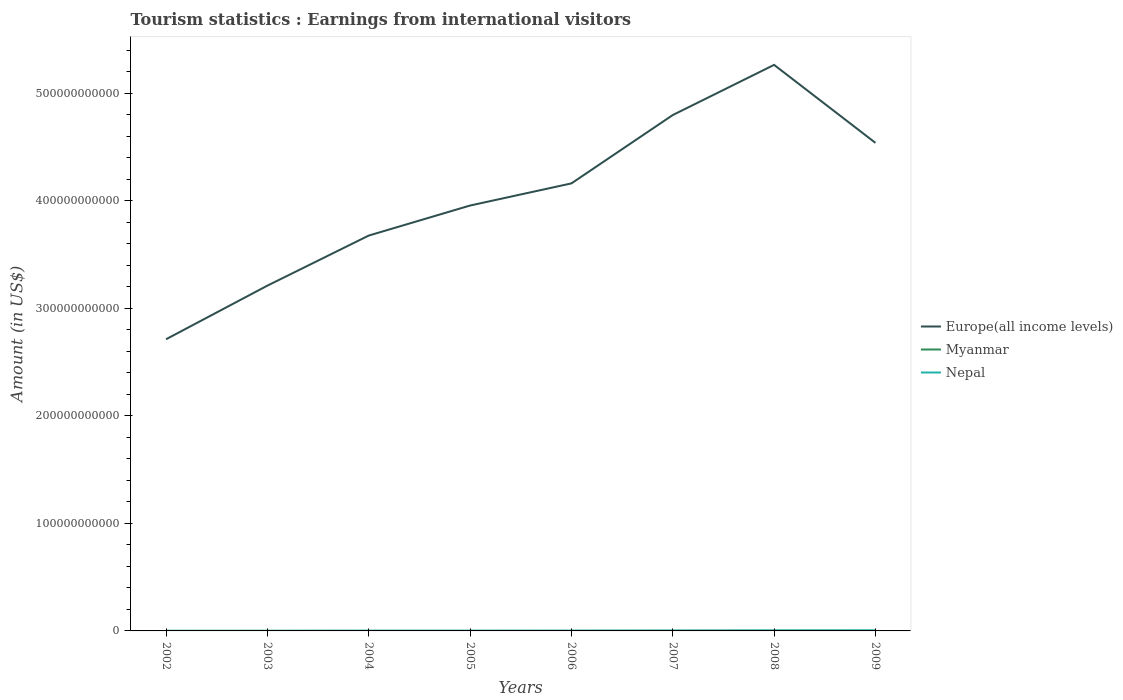How many different coloured lines are there?
Provide a succinct answer. 3. Is the number of lines equal to the number of legend labels?
Keep it short and to the point. Yes. Across all years, what is the maximum earnings from international visitors in Europe(all income levels)?
Offer a very short reply. 2.71e+11. What is the total earnings from international visitors in Europe(all income levels) in the graph?
Offer a terse response. -9.51e+1. What is the difference between the highest and the second highest earnings from international visitors in Europe(all income levels)?
Keep it short and to the point. 2.55e+11. What is the difference between two consecutive major ticks on the Y-axis?
Provide a succinct answer. 1.00e+11. Does the graph contain grids?
Offer a terse response. No. What is the title of the graph?
Provide a short and direct response. Tourism statistics : Earnings from international visitors. Does "Djibouti" appear as one of the legend labels in the graph?
Your response must be concise. No. What is the label or title of the Y-axis?
Give a very brief answer. Amount (in US$). What is the Amount (in US$) of Europe(all income levels) in 2002?
Offer a very short reply. 2.71e+11. What is the Amount (in US$) of Myanmar in 2002?
Your answer should be compact. 3.40e+07. What is the Amount (in US$) of Nepal in 2002?
Your answer should be compact. 1.08e+08. What is the Amount (in US$) of Europe(all income levels) in 2003?
Give a very brief answer. 3.21e+11. What is the Amount (in US$) in Myanmar in 2003?
Provide a short and direct response. 3.60e+07. What is the Amount (in US$) in Nepal in 2003?
Offer a terse response. 1.19e+08. What is the Amount (in US$) of Europe(all income levels) in 2004?
Your answer should be compact. 3.68e+11. What is the Amount (in US$) of Myanmar in 2004?
Your answer should be very brief. 3.20e+07. What is the Amount (in US$) in Nepal in 2004?
Offer a terse response. 2.05e+08. What is the Amount (in US$) of Europe(all income levels) in 2005?
Give a very brief answer. 3.96e+11. What is the Amount (in US$) in Myanmar in 2005?
Provide a short and direct response. 3.40e+07. What is the Amount (in US$) in Nepal in 2005?
Offer a very short reply. 2.21e+08. What is the Amount (in US$) in Europe(all income levels) in 2006?
Your answer should be compact. 4.16e+11. What is the Amount (in US$) of Myanmar in 2006?
Give a very brief answer. 4.00e+07. What is the Amount (in US$) in Nepal in 2006?
Ensure brevity in your answer.  2.61e+08. What is the Amount (in US$) of Europe(all income levels) in 2007?
Make the answer very short. 4.80e+11. What is the Amount (in US$) of Myanmar in 2007?
Provide a succinct answer. 3.90e+07. What is the Amount (in US$) of Nepal in 2007?
Give a very brief answer. 4.02e+08. What is the Amount (in US$) of Europe(all income levels) in 2008?
Provide a succinct answer. 5.26e+11. What is the Amount (in US$) in Myanmar in 2008?
Ensure brevity in your answer.  4.97e+07. What is the Amount (in US$) of Nepal in 2008?
Your answer should be very brief. 5.45e+08. What is the Amount (in US$) of Europe(all income levels) in 2009?
Give a very brief answer. 4.54e+11. What is the Amount (in US$) of Myanmar in 2009?
Keep it short and to the point. 5.20e+07. What is the Amount (in US$) in Nepal in 2009?
Give a very brief answer. 5.72e+08. Across all years, what is the maximum Amount (in US$) of Europe(all income levels)?
Give a very brief answer. 5.26e+11. Across all years, what is the maximum Amount (in US$) of Myanmar?
Your answer should be very brief. 5.20e+07. Across all years, what is the maximum Amount (in US$) in Nepal?
Provide a short and direct response. 5.72e+08. Across all years, what is the minimum Amount (in US$) of Europe(all income levels)?
Your response must be concise. 2.71e+11. Across all years, what is the minimum Amount (in US$) in Myanmar?
Offer a very short reply. 3.20e+07. Across all years, what is the minimum Amount (in US$) of Nepal?
Offer a very short reply. 1.08e+08. What is the total Amount (in US$) in Europe(all income levels) in the graph?
Your response must be concise. 3.23e+12. What is the total Amount (in US$) of Myanmar in the graph?
Your answer should be very brief. 3.17e+08. What is the total Amount (in US$) in Nepal in the graph?
Keep it short and to the point. 2.43e+09. What is the difference between the Amount (in US$) of Europe(all income levels) in 2002 and that in 2003?
Your answer should be compact. -4.99e+1. What is the difference between the Amount (in US$) in Myanmar in 2002 and that in 2003?
Keep it short and to the point. -2.00e+06. What is the difference between the Amount (in US$) of Nepal in 2002 and that in 2003?
Make the answer very short. -1.10e+07. What is the difference between the Amount (in US$) of Europe(all income levels) in 2002 and that in 2004?
Your response must be concise. -9.64e+1. What is the difference between the Amount (in US$) of Myanmar in 2002 and that in 2004?
Keep it short and to the point. 2.00e+06. What is the difference between the Amount (in US$) in Nepal in 2002 and that in 2004?
Your answer should be compact. -9.70e+07. What is the difference between the Amount (in US$) of Europe(all income levels) in 2002 and that in 2005?
Your response must be concise. -1.24e+11. What is the difference between the Amount (in US$) in Myanmar in 2002 and that in 2005?
Offer a terse response. 0. What is the difference between the Amount (in US$) of Nepal in 2002 and that in 2005?
Ensure brevity in your answer.  -1.13e+08. What is the difference between the Amount (in US$) of Europe(all income levels) in 2002 and that in 2006?
Provide a short and direct response. -1.45e+11. What is the difference between the Amount (in US$) of Myanmar in 2002 and that in 2006?
Your answer should be compact. -6.00e+06. What is the difference between the Amount (in US$) of Nepal in 2002 and that in 2006?
Your answer should be very brief. -1.53e+08. What is the difference between the Amount (in US$) in Europe(all income levels) in 2002 and that in 2007?
Ensure brevity in your answer.  -2.09e+11. What is the difference between the Amount (in US$) in Myanmar in 2002 and that in 2007?
Offer a terse response. -5.00e+06. What is the difference between the Amount (in US$) in Nepal in 2002 and that in 2007?
Give a very brief answer. -2.94e+08. What is the difference between the Amount (in US$) in Europe(all income levels) in 2002 and that in 2008?
Keep it short and to the point. -2.55e+11. What is the difference between the Amount (in US$) of Myanmar in 2002 and that in 2008?
Your response must be concise. -1.57e+07. What is the difference between the Amount (in US$) in Nepal in 2002 and that in 2008?
Keep it short and to the point. -4.37e+08. What is the difference between the Amount (in US$) of Europe(all income levels) in 2002 and that in 2009?
Your response must be concise. -1.83e+11. What is the difference between the Amount (in US$) of Myanmar in 2002 and that in 2009?
Offer a very short reply. -1.80e+07. What is the difference between the Amount (in US$) of Nepal in 2002 and that in 2009?
Offer a very short reply. -4.64e+08. What is the difference between the Amount (in US$) in Europe(all income levels) in 2003 and that in 2004?
Offer a very short reply. -4.66e+1. What is the difference between the Amount (in US$) of Myanmar in 2003 and that in 2004?
Ensure brevity in your answer.  4.00e+06. What is the difference between the Amount (in US$) in Nepal in 2003 and that in 2004?
Give a very brief answer. -8.60e+07. What is the difference between the Amount (in US$) in Europe(all income levels) in 2003 and that in 2005?
Ensure brevity in your answer.  -7.45e+1. What is the difference between the Amount (in US$) of Myanmar in 2003 and that in 2005?
Make the answer very short. 2.00e+06. What is the difference between the Amount (in US$) in Nepal in 2003 and that in 2005?
Offer a terse response. -1.02e+08. What is the difference between the Amount (in US$) of Europe(all income levels) in 2003 and that in 2006?
Your response must be concise. -9.51e+1. What is the difference between the Amount (in US$) in Nepal in 2003 and that in 2006?
Your answer should be very brief. -1.42e+08. What is the difference between the Amount (in US$) of Europe(all income levels) in 2003 and that in 2007?
Your response must be concise. -1.59e+11. What is the difference between the Amount (in US$) in Myanmar in 2003 and that in 2007?
Provide a short and direct response. -3.00e+06. What is the difference between the Amount (in US$) of Nepal in 2003 and that in 2007?
Your answer should be very brief. -2.83e+08. What is the difference between the Amount (in US$) in Europe(all income levels) in 2003 and that in 2008?
Give a very brief answer. -2.05e+11. What is the difference between the Amount (in US$) in Myanmar in 2003 and that in 2008?
Offer a very short reply. -1.37e+07. What is the difference between the Amount (in US$) in Nepal in 2003 and that in 2008?
Give a very brief answer. -4.26e+08. What is the difference between the Amount (in US$) of Europe(all income levels) in 2003 and that in 2009?
Your answer should be compact. -1.33e+11. What is the difference between the Amount (in US$) in Myanmar in 2003 and that in 2009?
Offer a very short reply. -1.60e+07. What is the difference between the Amount (in US$) in Nepal in 2003 and that in 2009?
Offer a very short reply. -4.53e+08. What is the difference between the Amount (in US$) in Europe(all income levels) in 2004 and that in 2005?
Keep it short and to the point. -2.79e+1. What is the difference between the Amount (in US$) in Myanmar in 2004 and that in 2005?
Make the answer very short. -2.00e+06. What is the difference between the Amount (in US$) in Nepal in 2004 and that in 2005?
Keep it short and to the point. -1.60e+07. What is the difference between the Amount (in US$) of Europe(all income levels) in 2004 and that in 2006?
Ensure brevity in your answer.  -4.85e+1. What is the difference between the Amount (in US$) in Myanmar in 2004 and that in 2006?
Your answer should be compact. -8.00e+06. What is the difference between the Amount (in US$) in Nepal in 2004 and that in 2006?
Your answer should be compact. -5.60e+07. What is the difference between the Amount (in US$) in Europe(all income levels) in 2004 and that in 2007?
Your answer should be very brief. -1.12e+11. What is the difference between the Amount (in US$) of Myanmar in 2004 and that in 2007?
Your response must be concise. -7.00e+06. What is the difference between the Amount (in US$) in Nepal in 2004 and that in 2007?
Offer a terse response. -1.97e+08. What is the difference between the Amount (in US$) of Europe(all income levels) in 2004 and that in 2008?
Give a very brief answer. -1.59e+11. What is the difference between the Amount (in US$) of Myanmar in 2004 and that in 2008?
Offer a very short reply. -1.77e+07. What is the difference between the Amount (in US$) of Nepal in 2004 and that in 2008?
Make the answer very short. -3.40e+08. What is the difference between the Amount (in US$) of Europe(all income levels) in 2004 and that in 2009?
Keep it short and to the point. -8.62e+1. What is the difference between the Amount (in US$) of Myanmar in 2004 and that in 2009?
Your answer should be compact. -2.00e+07. What is the difference between the Amount (in US$) in Nepal in 2004 and that in 2009?
Your answer should be very brief. -3.67e+08. What is the difference between the Amount (in US$) of Europe(all income levels) in 2005 and that in 2006?
Give a very brief answer. -2.06e+1. What is the difference between the Amount (in US$) in Myanmar in 2005 and that in 2006?
Make the answer very short. -6.00e+06. What is the difference between the Amount (in US$) in Nepal in 2005 and that in 2006?
Make the answer very short. -4.00e+07. What is the difference between the Amount (in US$) of Europe(all income levels) in 2005 and that in 2007?
Your answer should be very brief. -8.42e+1. What is the difference between the Amount (in US$) of Myanmar in 2005 and that in 2007?
Provide a succinct answer. -5.00e+06. What is the difference between the Amount (in US$) of Nepal in 2005 and that in 2007?
Your response must be concise. -1.81e+08. What is the difference between the Amount (in US$) in Europe(all income levels) in 2005 and that in 2008?
Keep it short and to the point. -1.31e+11. What is the difference between the Amount (in US$) in Myanmar in 2005 and that in 2008?
Provide a short and direct response. -1.57e+07. What is the difference between the Amount (in US$) of Nepal in 2005 and that in 2008?
Offer a very short reply. -3.24e+08. What is the difference between the Amount (in US$) in Europe(all income levels) in 2005 and that in 2009?
Provide a short and direct response. -5.83e+1. What is the difference between the Amount (in US$) of Myanmar in 2005 and that in 2009?
Provide a succinct answer. -1.80e+07. What is the difference between the Amount (in US$) in Nepal in 2005 and that in 2009?
Your answer should be compact. -3.51e+08. What is the difference between the Amount (in US$) of Europe(all income levels) in 2006 and that in 2007?
Provide a succinct answer. -6.36e+1. What is the difference between the Amount (in US$) of Myanmar in 2006 and that in 2007?
Your answer should be compact. 1.00e+06. What is the difference between the Amount (in US$) in Nepal in 2006 and that in 2007?
Give a very brief answer. -1.41e+08. What is the difference between the Amount (in US$) of Europe(all income levels) in 2006 and that in 2008?
Give a very brief answer. -1.10e+11. What is the difference between the Amount (in US$) of Myanmar in 2006 and that in 2008?
Your answer should be very brief. -9.70e+06. What is the difference between the Amount (in US$) of Nepal in 2006 and that in 2008?
Offer a terse response. -2.84e+08. What is the difference between the Amount (in US$) of Europe(all income levels) in 2006 and that in 2009?
Your answer should be compact. -3.77e+1. What is the difference between the Amount (in US$) in Myanmar in 2006 and that in 2009?
Provide a succinct answer. -1.20e+07. What is the difference between the Amount (in US$) in Nepal in 2006 and that in 2009?
Your response must be concise. -3.11e+08. What is the difference between the Amount (in US$) of Europe(all income levels) in 2007 and that in 2008?
Offer a very short reply. -4.67e+1. What is the difference between the Amount (in US$) in Myanmar in 2007 and that in 2008?
Offer a very short reply. -1.07e+07. What is the difference between the Amount (in US$) in Nepal in 2007 and that in 2008?
Give a very brief answer. -1.43e+08. What is the difference between the Amount (in US$) of Europe(all income levels) in 2007 and that in 2009?
Keep it short and to the point. 2.59e+1. What is the difference between the Amount (in US$) of Myanmar in 2007 and that in 2009?
Your answer should be compact. -1.30e+07. What is the difference between the Amount (in US$) in Nepal in 2007 and that in 2009?
Your response must be concise. -1.70e+08. What is the difference between the Amount (in US$) of Europe(all income levels) in 2008 and that in 2009?
Your answer should be very brief. 7.25e+1. What is the difference between the Amount (in US$) in Myanmar in 2008 and that in 2009?
Give a very brief answer. -2.30e+06. What is the difference between the Amount (in US$) of Nepal in 2008 and that in 2009?
Your answer should be compact. -2.70e+07. What is the difference between the Amount (in US$) in Europe(all income levels) in 2002 and the Amount (in US$) in Myanmar in 2003?
Your answer should be compact. 2.71e+11. What is the difference between the Amount (in US$) in Europe(all income levels) in 2002 and the Amount (in US$) in Nepal in 2003?
Make the answer very short. 2.71e+11. What is the difference between the Amount (in US$) in Myanmar in 2002 and the Amount (in US$) in Nepal in 2003?
Your answer should be very brief. -8.50e+07. What is the difference between the Amount (in US$) of Europe(all income levels) in 2002 and the Amount (in US$) of Myanmar in 2004?
Make the answer very short. 2.71e+11. What is the difference between the Amount (in US$) of Europe(all income levels) in 2002 and the Amount (in US$) of Nepal in 2004?
Your answer should be very brief. 2.71e+11. What is the difference between the Amount (in US$) of Myanmar in 2002 and the Amount (in US$) of Nepal in 2004?
Your answer should be very brief. -1.71e+08. What is the difference between the Amount (in US$) in Europe(all income levels) in 2002 and the Amount (in US$) in Myanmar in 2005?
Your response must be concise. 2.71e+11. What is the difference between the Amount (in US$) of Europe(all income levels) in 2002 and the Amount (in US$) of Nepal in 2005?
Keep it short and to the point. 2.71e+11. What is the difference between the Amount (in US$) in Myanmar in 2002 and the Amount (in US$) in Nepal in 2005?
Provide a short and direct response. -1.87e+08. What is the difference between the Amount (in US$) of Europe(all income levels) in 2002 and the Amount (in US$) of Myanmar in 2006?
Give a very brief answer. 2.71e+11. What is the difference between the Amount (in US$) of Europe(all income levels) in 2002 and the Amount (in US$) of Nepal in 2006?
Make the answer very short. 2.71e+11. What is the difference between the Amount (in US$) of Myanmar in 2002 and the Amount (in US$) of Nepal in 2006?
Provide a succinct answer. -2.27e+08. What is the difference between the Amount (in US$) in Europe(all income levels) in 2002 and the Amount (in US$) in Myanmar in 2007?
Offer a terse response. 2.71e+11. What is the difference between the Amount (in US$) of Europe(all income levels) in 2002 and the Amount (in US$) of Nepal in 2007?
Keep it short and to the point. 2.71e+11. What is the difference between the Amount (in US$) of Myanmar in 2002 and the Amount (in US$) of Nepal in 2007?
Offer a terse response. -3.68e+08. What is the difference between the Amount (in US$) in Europe(all income levels) in 2002 and the Amount (in US$) in Myanmar in 2008?
Your answer should be compact. 2.71e+11. What is the difference between the Amount (in US$) of Europe(all income levels) in 2002 and the Amount (in US$) of Nepal in 2008?
Offer a very short reply. 2.71e+11. What is the difference between the Amount (in US$) of Myanmar in 2002 and the Amount (in US$) of Nepal in 2008?
Your answer should be compact. -5.11e+08. What is the difference between the Amount (in US$) of Europe(all income levels) in 2002 and the Amount (in US$) of Myanmar in 2009?
Offer a terse response. 2.71e+11. What is the difference between the Amount (in US$) in Europe(all income levels) in 2002 and the Amount (in US$) in Nepal in 2009?
Keep it short and to the point. 2.71e+11. What is the difference between the Amount (in US$) of Myanmar in 2002 and the Amount (in US$) of Nepal in 2009?
Your response must be concise. -5.38e+08. What is the difference between the Amount (in US$) of Europe(all income levels) in 2003 and the Amount (in US$) of Myanmar in 2004?
Give a very brief answer. 3.21e+11. What is the difference between the Amount (in US$) in Europe(all income levels) in 2003 and the Amount (in US$) in Nepal in 2004?
Ensure brevity in your answer.  3.21e+11. What is the difference between the Amount (in US$) in Myanmar in 2003 and the Amount (in US$) in Nepal in 2004?
Make the answer very short. -1.69e+08. What is the difference between the Amount (in US$) in Europe(all income levels) in 2003 and the Amount (in US$) in Myanmar in 2005?
Give a very brief answer. 3.21e+11. What is the difference between the Amount (in US$) in Europe(all income levels) in 2003 and the Amount (in US$) in Nepal in 2005?
Offer a terse response. 3.21e+11. What is the difference between the Amount (in US$) of Myanmar in 2003 and the Amount (in US$) of Nepal in 2005?
Give a very brief answer. -1.85e+08. What is the difference between the Amount (in US$) in Europe(all income levels) in 2003 and the Amount (in US$) in Myanmar in 2006?
Offer a very short reply. 3.21e+11. What is the difference between the Amount (in US$) in Europe(all income levels) in 2003 and the Amount (in US$) in Nepal in 2006?
Offer a very short reply. 3.21e+11. What is the difference between the Amount (in US$) of Myanmar in 2003 and the Amount (in US$) of Nepal in 2006?
Give a very brief answer. -2.25e+08. What is the difference between the Amount (in US$) of Europe(all income levels) in 2003 and the Amount (in US$) of Myanmar in 2007?
Provide a short and direct response. 3.21e+11. What is the difference between the Amount (in US$) of Europe(all income levels) in 2003 and the Amount (in US$) of Nepal in 2007?
Offer a terse response. 3.21e+11. What is the difference between the Amount (in US$) of Myanmar in 2003 and the Amount (in US$) of Nepal in 2007?
Your response must be concise. -3.66e+08. What is the difference between the Amount (in US$) of Europe(all income levels) in 2003 and the Amount (in US$) of Myanmar in 2008?
Offer a very short reply. 3.21e+11. What is the difference between the Amount (in US$) of Europe(all income levels) in 2003 and the Amount (in US$) of Nepal in 2008?
Keep it short and to the point. 3.21e+11. What is the difference between the Amount (in US$) of Myanmar in 2003 and the Amount (in US$) of Nepal in 2008?
Keep it short and to the point. -5.09e+08. What is the difference between the Amount (in US$) in Europe(all income levels) in 2003 and the Amount (in US$) in Myanmar in 2009?
Offer a terse response. 3.21e+11. What is the difference between the Amount (in US$) in Europe(all income levels) in 2003 and the Amount (in US$) in Nepal in 2009?
Ensure brevity in your answer.  3.21e+11. What is the difference between the Amount (in US$) of Myanmar in 2003 and the Amount (in US$) of Nepal in 2009?
Offer a terse response. -5.36e+08. What is the difference between the Amount (in US$) of Europe(all income levels) in 2004 and the Amount (in US$) of Myanmar in 2005?
Your answer should be compact. 3.68e+11. What is the difference between the Amount (in US$) in Europe(all income levels) in 2004 and the Amount (in US$) in Nepal in 2005?
Your answer should be compact. 3.67e+11. What is the difference between the Amount (in US$) of Myanmar in 2004 and the Amount (in US$) of Nepal in 2005?
Ensure brevity in your answer.  -1.89e+08. What is the difference between the Amount (in US$) in Europe(all income levels) in 2004 and the Amount (in US$) in Myanmar in 2006?
Offer a very short reply. 3.68e+11. What is the difference between the Amount (in US$) in Europe(all income levels) in 2004 and the Amount (in US$) in Nepal in 2006?
Offer a terse response. 3.67e+11. What is the difference between the Amount (in US$) of Myanmar in 2004 and the Amount (in US$) of Nepal in 2006?
Give a very brief answer. -2.29e+08. What is the difference between the Amount (in US$) of Europe(all income levels) in 2004 and the Amount (in US$) of Myanmar in 2007?
Offer a very short reply. 3.68e+11. What is the difference between the Amount (in US$) of Europe(all income levels) in 2004 and the Amount (in US$) of Nepal in 2007?
Offer a very short reply. 3.67e+11. What is the difference between the Amount (in US$) of Myanmar in 2004 and the Amount (in US$) of Nepal in 2007?
Ensure brevity in your answer.  -3.70e+08. What is the difference between the Amount (in US$) in Europe(all income levels) in 2004 and the Amount (in US$) in Myanmar in 2008?
Your response must be concise. 3.68e+11. What is the difference between the Amount (in US$) of Europe(all income levels) in 2004 and the Amount (in US$) of Nepal in 2008?
Your answer should be very brief. 3.67e+11. What is the difference between the Amount (in US$) of Myanmar in 2004 and the Amount (in US$) of Nepal in 2008?
Provide a short and direct response. -5.13e+08. What is the difference between the Amount (in US$) in Europe(all income levels) in 2004 and the Amount (in US$) in Myanmar in 2009?
Ensure brevity in your answer.  3.68e+11. What is the difference between the Amount (in US$) in Europe(all income levels) in 2004 and the Amount (in US$) in Nepal in 2009?
Ensure brevity in your answer.  3.67e+11. What is the difference between the Amount (in US$) of Myanmar in 2004 and the Amount (in US$) of Nepal in 2009?
Give a very brief answer. -5.40e+08. What is the difference between the Amount (in US$) in Europe(all income levels) in 2005 and the Amount (in US$) in Myanmar in 2006?
Make the answer very short. 3.96e+11. What is the difference between the Amount (in US$) of Europe(all income levels) in 2005 and the Amount (in US$) of Nepal in 2006?
Make the answer very short. 3.95e+11. What is the difference between the Amount (in US$) of Myanmar in 2005 and the Amount (in US$) of Nepal in 2006?
Offer a very short reply. -2.27e+08. What is the difference between the Amount (in US$) in Europe(all income levels) in 2005 and the Amount (in US$) in Myanmar in 2007?
Your answer should be very brief. 3.96e+11. What is the difference between the Amount (in US$) of Europe(all income levels) in 2005 and the Amount (in US$) of Nepal in 2007?
Keep it short and to the point. 3.95e+11. What is the difference between the Amount (in US$) of Myanmar in 2005 and the Amount (in US$) of Nepal in 2007?
Provide a succinct answer. -3.68e+08. What is the difference between the Amount (in US$) of Europe(all income levels) in 2005 and the Amount (in US$) of Myanmar in 2008?
Provide a short and direct response. 3.96e+11. What is the difference between the Amount (in US$) of Europe(all income levels) in 2005 and the Amount (in US$) of Nepal in 2008?
Provide a succinct answer. 3.95e+11. What is the difference between the Amount (in US$) in Myanmar in 2005 and the Amount (in US$) in Nepal in 2008?
Give a very brief answer. -5.11e+08. What is the difference between the Amount (in US$) in Europe(all income levels) in 2005 and the Amount (in US$) in Myanmar in 2009?
Provide a succinct answer. 3.96e+11. What is the difference between the Amount (in US$) of Europe(all income levels) in 2005 and the Amount (in US$) of Nepal in 2009?
Offer a terse response. 3.95e+11. What is the difference between the Amount (in US$) in Myanmar in 2005 and the Amount (in US$) in Nepal in 2009?
Your response must be concise. -5.38e+08. What is the difference between the Amount (in US$) in Europe(all income levels) in 2006 and the Amount (in US$) in Myanmar in 2007?
Provide a short and direct response. 4.16e+11. What is the difference between the Amount (in US$) in Europe(all income levels) in 2006 and the Amount (in US$) in Nepal in 2007?
Your answer should be compact. 4.16e+11. What is the difference between the Amount (in US$) of Myanmar in 2006 and the Amount (in US$) of Nepal in 2007?
Offer a terse response. -3.62e+08. What is the difference between the Amount (in US$) of Europe(all income levels) in 2006 and the Amount (in US$) of Myanmar in 2008?
Provide a short and direct response. 4.16e+11. What is the difference between the Amount (in US$) of Europe(all income levels) in 2006 and the Amount (in US$) of Nepal in 2008?
Your response must be concise. 4.16e+11. What is the difference between the Amount (in US$) of Myanmar in 2006 and the Amount (in US$) of Nepal in 2008?
Your answer should be compact. -5.05e+08. What is the difference between the Amount (in US$) in Europe(all income levels) in 2006 and the Amount (in US$) in Myanmar in 2009?
Offer a very short reply. 4.16e+11. What is the difference between the Amount (in US$) of Europe(all income levels) in 2006 and the Amount (in US$) of Nepal in 2009?
Provide a succinct answer. 4.16e+11. What is the difference between the Amount (in US$) of Myanmar in 2006 and the Amount (in US$) of Nepal in 2009?
Offer a very short reply. -5.32e+08. What is the difference between the Amount (in US$) of Europe(all income levels) in 2007 and the Amount (in US$) of Myanmar in 2008?
Provide a short and direct response. 4.80e+11. What is the difference between the Amount (in US$) in Europe(all income levels) in 2007 and the Amount (in US$) in Nepal in 2008?
Provide a succinct answer. 4.79e+11. What is the difference between the Amount (in US$) in Myanmar in 2007 and the Amount (in US$) in Nepal in 2008?
Your response must be concise. -5.06e+08. What is the difference between the Amount (in US$) of Europe(all income levels) in 2007 and the Amount (in US$) of Myanmar in 2009?
Make the answer very short. 4.80e+11. What is the difference between the Amount (in US$) in Europe(all income levels) in 2007 and the Amount (in US$) in Nepal in 2009?
Provide a short and direct response. 4.79e+11. What is the difference between the Amount (in US$) of Myanmar in 2007 and the Amount (in US$) of Nepal in 2009?
Give a very brief answer. -5.33e+08. What is the difference between the Amount (in US$) of Europe(all income levels) in 2008 and the Amount (in US$) of Myanmar in 2009?
Give a very brief answer. 5.26e+11. What is the difference between the Amount (in US$) of Europe(all income levels) in 2008 and the Amount (in US$) of Nepal in 2009?
Your answer should be very brief. 5.26e+11. What is the difference between the Amount (in US$) in Myanmar in 2008 and the Amount (in US$) in Nepal in 2009?
Your response must be concise. -5.22e+08. What is the average Amount (in US$) in Europe(all income levels) per year?
Give a very brief answer. 4.04e+11. What is the average Amount (in US$) of Myanmar per year?
Offer a very short reply. 3.96e+07. What is the average Amount (in US$) in Nepal per year?
Give a very brief answer. 3.04e+08. In the year 2002, what is the difference between the Amount (in US$) of Europe(all income levels) and Amount (in US$) of Myanmar?
Offer a very short reply. 2.71e+11. In the year 2002, what is the difference between the Amount (in US$) of Europe(all income levels) and Amount (in US$) of Nepal?
Keep it short and to the point. 2.71e+11. In the year 2002, what is the difference between the Amount (in US$) of Myanmar and Amount (in US$) of Nepal?
Offer a terse response. -7.40e+07. In the year 2003, what is the difference between the Amount (in US$) of Europe(all income levels) and Amount (in US$) of Myanmar?
Give a very brief answer. 3.21e+11. In the year 2003, what is the difference between the Amount (in US$) of Europe(all income levels) and Amount (in US$) of Nepal?
Offer a terse response. 3.21e+11. In the year 2003, what is the difference between the Amount (in US$) in Myanmar and Amount (in US$) in Nepal?
Your answer should be very brief. -8.30e+07. In the year 2004, what is the difference between the Amount (in US$) in Europe(all income levels) and Amount (in US$) in Myanmar?
Your answer should be very brief. 3.68e+11. In the year 2004, what is the difference between the Amount (in US$) of Europe(all income levels) and Amount (in US$) of Nepal?
Ensure brevity in your answer.  3.67e+11. In the year 2004, what is the difference between the Amount (in US$) of Myanmar and Amount (in US$) of Nepal?
Your response must be concise. -1.73e+08. In the year 2005, what is the difference between the Amount (in US$) of Europe(all income levels) and Amount (in US$) of Myanmar?
Your response must be concise. 3.96e+11. In the year 2005, what is the difference between the Amount (in US$) in Europe(all income levels) and Amount (in US$) in Nepal?
Offer a very short reply. 3.95e+11. In the year 2005, what is the difference between the Amount (in US$) in Myanmar and Amount (in US$) in Nepal?
Ensure brevity in your answer.  -1.87e+08. In the year 2006, what is the difference between the Amount (in US$) of Europe(all income levels) and Amount (in US$) of Myanmar?
Your answer should be compact. 4.16e+11. In the year 2006, what is the difference between the Amount (in US$) in Europe(all income levels) and Amount (in US$) in Nepal?
Offer a very short reply. 4.16e+11. In the year 2006, what is the difference between the Amount (in US$) in Myanmar and Amount (in US$) in Nepal?
Ensure brevity in your answer.  -2.21e+08. In the year 2007, what is the difference between the Amount (in US$) of Europe(all income levels) and Amount (in US$) of Myanmar?
Your answer should be compact. 4.80e+11. In the year 2007, what is the difference between the Amount (in US$) of Europe(all income levels) and Amount (in US$) of Nepal?
Make the answer very short. 4.79e+11. In the year 2007, what is the difference between the Amount (in US$) of Myanmar and Amount (in US$) of Nepal?
Give a very brief answer. -3.63e+08. In the year 2008, what is the difference between the Amount (in US$) of Europe(all income levels) and Amount (in US$) of Myanmar?
Keep it short and to the point. 5.26e+11. In the year 2008, what is the difference between the Amount (in US$) in Europe(all income levels) and Amount (in US$) in Nepal?
Your response must be concise. 5.26e+11. In the year 2008, what is the difference between the Amount (in US$) of Myanmar and Amount (in US$) of Nepal?
Provide a short and direct response. -4.95e+08. In the year 2009, what is the difference between the Amount (in US$) in Europe(all income levels) and Amount (in US$) in Myanmar?
Keep it short and to the point. 4.54e+11. In the year 2009, what is the difference between the Amount (in US$) of Europe(all income levels) and Amount (in US$) of Nepal?
Give a very brief answer. 4.53e+11. In the year 2009, what is the difference between the Amount (in US$) in Myanmar and Amount (in US$) in Nepal?
Offer a terse response. -5.20e+08. What is the ratio of the Amount (in US$) of Europe(all income levels) in 2002 to that in 2003?
Offer a very short reply. 0.84. What is the ratio of the Amount (in US$) in Myanmar in 2002 to that in 2003?
Your response must be concise. 0.94. What is the ratio of the Amount (in US$) of Nepal in 2002 to that in 2003?
Make the answer very short. 0.91. What is the ratio of the Amount (in US$) of Europe(all income levels) in 2002 to that in 2004?
Provide a succinct answer. 0.74. What is the ratio of the Amount (in US$) of Myanmar in 2002 to that in 2004?
Keep it short and to the point. 1.06. What is the ratio of the Amount (in US$) in Nepal in 2002 to that in 2004?
Keep it short and to the point. 0.53. What is the ratio of the Amount (in US$) of Europe(all income levels) in 2002 to that in 2005?
Your answer should be very brief. 0.69. What is the ratio of the Amount (in US$) of Myanmar in 2002 to that in 2005?
Give a very brief answer. 1. What is the ratio of the Amount (in US$) of Nepal in 2002 to that in 2005?
Your answer should be very brief. 0.49. What is the ratio of the Amount (in US$) of Europe(all income levels) in 2002 to that in 2006?
Your answer should be compact. 0.65. What is the ratio of the Amount (in US$) of Myanmar in 2002 to that in 2006?
Your answer should be very brief. 0.85. What is the ratio of the Amount (in US$) of Nepal in 2002 to that in 2006?
Your answer should be very brief. 0.41. What is the ratio of the Amount (in US$) of Europe(all income levels) in 2002 to that in 2007?
Your response must be concise. 0.57. What is the ratio of the Amount (in US$) in Myanmar in 2002 to that in 2007?
Your response must be concise. 0.87. What is the ratio of the Amount (in US$) of Nepal in 2002 to that in 2007?
Keep it short and to the point. 0.27. What is the ratio of the Amount (in US$) of Europe(all income levels) in 2002 to that in 2008?
Make the answer very short. 0.52. What is the ratio of the Amount (in US$) of Myanmar in 2002 to that in 2008?
Ensure brevity in your answer.  0.68. What is the ratio of the Amount (in US$) in Nepal in 2002 to that in 2008?
Give a very brief answer. 0.2. What is the ratio of the Amount (in US$) in Europe(all income levels) in 2002 to that in 2009?
Give a very brief answer. 0.6. What is the ratio of the Amount (in US$) in Myanmar in 2002 to that in 2009?
Offer a very short reply. 0.65. What is the ratio of the Amount (in US$) in Nepal in 2002 to that in 2009?
Offer a terse response. 0.19. What is the ratio of the Amount (in US$) of Europe(all income levels) in 2003 to that in 2004?
Provide a short and direct response. 0.87. What is the ratio of the Amount (in US$) of Myanmar in 2003 to that in 2004?
Keep it short and to the point. 1.12. What is the ratio of the Amount (in US$) in Nepal in 2003 to that in 2004?
Your answer should be very brief. 0.58. What is the ratio of the Amount (in US$) of Europe(all income levels) in 2003 to that in 2005?
Your response must be concise. 0.81. What is the ratio of the Amount (in US$) of Myanmar in 2003 to that in 2005?
Offer a very short reply. 1.06. What is the ratio of the Amount (in US$) in Nepal in 2003 to that in 2005?
Ensure brevity in your answer.  0.54. What is the ratio of the Amount (in US$) in Europe(all income levels) in 2003 to that in 2006?
Your answer should be very brief. 0.77. What is the ratio of the Amount (in US$) in Nepal in 2003 to that in 2006?
Make the answer very short. 0.46. What is the ratio of the Amount (in US$) in Europe(all income levels) in 2003 to that in 2007?
Offer a very short reply. 0.67. What is the ratio of the Amount (in US$) in Nepal in 2003 to that in 2007?
Provide a short and direct response. 0.3. What is the ratio of the Amount (in US$) of Europe(all income levels) in 2003 to that in 2008?
Offer a very short reply. 0.61. What is the ratio of the Amount (in US$) of Myanmar in 2003 to that in 2008?
Your response must be concise. 0.72. What is the ratio of the Amount (in US$) in Nepal in 2003 to that in 2008?
Provide a succinct answer. 0.22. What is the ratio of the Amount (in US$) of Europe(all income levels) in 2003 to that in 2009?
Provide a short and direct response. 0.71. What is the ratio of the Amount (in US$) of Myanmar in 2003 to that in 2009?
Give a very brief answer. 0.69. What is the ratio of the Amount (in US$) in Nepal in 2003 to that in 2009?
Your response must be concise. 0.21. What is the ratio of the Amount (in US$) of Europe(all income levels) in 2004 to that in 2005?
Keep it short and to the point. 0.93. What is the ratio of the Amount (in US$) in Myanmar in 2004 to that in 2005?
Your response must be concise. 0.94. What is the ratio of the Amount (in US$) of Nepal in 2004 to that in 2005?
Keep it short and to the point. 0.93. What is the ratio of the Amount (in US$) of Europe(all income levels) in 2004 to that in 2006?
Your response must be concise. 0.88. What is the ratio of the Amount (in US$) in Nepal in 2004 to that in 2006?
Your answer should be very brief. 0.79. What is the ratio of the Amount (in US$) of Europe(all income levels) in 2004 to that in 2007?
Your answer should be compact. 0.77. What is the ratio of the Amount (in US$) in Myanmar in 2004 to that in 2007?
Your response must be concise. 0.82. What is the ratio of the Amount (in US$) of Nepal in 2004 to that in 2007?
Your answer should be compact. 0.51. What is the ratio of the Amount (in US$) of Europe(all income levels) in 2004 to that in 2008?
Provide a short and direct response. 0.7. What is the ratio of the Amount (in US$) of Myanmar in 2004 to that in 2008?
Offer a very short reply. 0.64. What is the ratio of the Amount (in US$) in Nepal in 2004 to that in 2008?
Provide a short and direct response. 0.38. What is the ratio of the Amount (in US$) in Europe(all income levels) in 2004 to that in 2009?
Ensure brevity in your answer.  0.81. What is the ratio of the Amount (in US$) in Myanmar in 2004 to that in 2009?
Offer a very short reply. 0.62. What is the ratio of the Amount (in US$) of Nepal in 2004 to that in 2009?
Make the answer very short. 0.36. What is the ratio of the Amount (in US$) in Europe(all income levels) in 2005 to that in 2006?
Offer a terse response. 0.95. What is the ratio of the Amount (in US$) of Myanmar in 2005 to that in 2006?
Make the answer very short. 0.85. What is the ratio of the Amount (in US$) in Nepal in 2005 to that in 2006?
Keep it short and to the point. 0.85. What is the ratio of the Amount (in US$) of Europe(all income levels) in 2005 to that in 2007?
Offer a very short reply. 0.82. What is the ratio of the Amount (in US$) of Myanmar in 2005 to that in 2007?
Keep it short and to the point. 0.87. What is the ratio of the Amount (in US$) of Nepal in 2005 to that in 2007?
Offer a very short reply. 0.55. What is the ratio of the Amount (in US$) of Europe(all income levels) in 2005 to that in 2008?
Your response must be concise. 0.75. What is the ratio of the Amount (in US$) in Myanmar in 2005 to that in 2008?
Keep it short and to the point. 0.68. What is the ratio of the Amount (in US$) in Nepal in 2005 to that in 2008?
Offer a very short reply. 0.41. What is the ratio of the Amount (in US$) of Europe(all income levels) in 2005 to that in 2009?
Offer a very short reply. 0.87. What is the ratio of the Amount (in US$) of Myanmar in 2005 to that in 2009?
Provide a short and direct response. 0.65. What is the ratio of the Amount (in US$) in Nepal in 2005 to that in 2009?
Offer a terse response. 0.39. What is the ratio of the Amount (in US$) in Europe(all income levels) in 2006 to that in 2007?
Your response must be concise. 0.87. What is the ratio of the Amount (in US$) of Myanmar in 2006 to that in 2007?
Make the answer very short. 1.03. What is the ratio of the Amount (in US$) in Nepal in 2006 to that in 2007?
Keep it short and to the point. 0.65. What is the ratio of the Amount (in US$) in Europe(all income levels) in 2006 to that in 2008?
Your response must be concise. 0.79. What is the ratio of the Amount (in US$) in Myanmar in 2006 to that in 2008?
Provide a short and direct response. 0.8. What is the ratio of the Amount (in US$) of Nepal in 2006 to that in 2008?
Provide a short and direct response. 0.48. What is the ratio of the Amount (in US$) of Europe(all income levels) in 2006 to that in 2009?
Ensure brevity in your answer.  0.92. What is the ratio of the Amount (in US$) in Myanmar in 2006 to that in 2009?
Keep it short and to the point. 0.77. What is the ratio of the Amount (in US$) in Nepal in 2006 to that in 2009?
Offer a terse response. 0.46. What is the ratio of the Amount (in US$) of Europe(all income levels) in 2007 to that in 2008?
Give a very brief answer. 0.91. What is the ratio of the Amount (in US$) of Myanmar in 2007 to that in 2008?
Give a very brief answer. 0.78. What is the ratio of the Amount (in US$) of Nepal in 2007 to that in 2008?
Ensure brevity in your answer.  0.74. What is the ratio of the Amount (in US$) of Europe(all income levels) in 2007 to that in 2009?
Provide a short and direct response. 1.06. What is the ratio of the Amount (in US$) of Nepal in 2007 to that in 2009?
Provide a short and direct response. 0.7. What is the ratio of the Amount (in US$) of Europe(all income levels) in 2008 to that in 2009?
Offer a terse response. 1.16. What is the ratio of the Amount (in US$) of Myanmar in 2008 to that in 2009?
Make the answer very short. 0.96. What is the ratio of the Amount (in US$) in Nepal in 2008 to that in 2009?
Your response must be concise. 0.95. What is the difference between the highest and the second highest Amount (in US$) of Europe(all income levels)?
Provide a succinct answer. 4.67e+1. What is the difference between the highest and the second highest Amount (in US$) of Myanmar?
Your answer should be very brief. 2.30e+06. What is the difference between the highest and the second highest Amount (in US$) in Nepal?
Keep it short and to the point. 2.70e+07. What is the difference between the highest and the lowest Amount (in US$) in Europe(all income levels)?
Offer a terse response. 2.55e+11. What is the difference between the highest and the lowest Amount (in US$) of Nepal?
Your answer should be compact. 4.64e+08. 